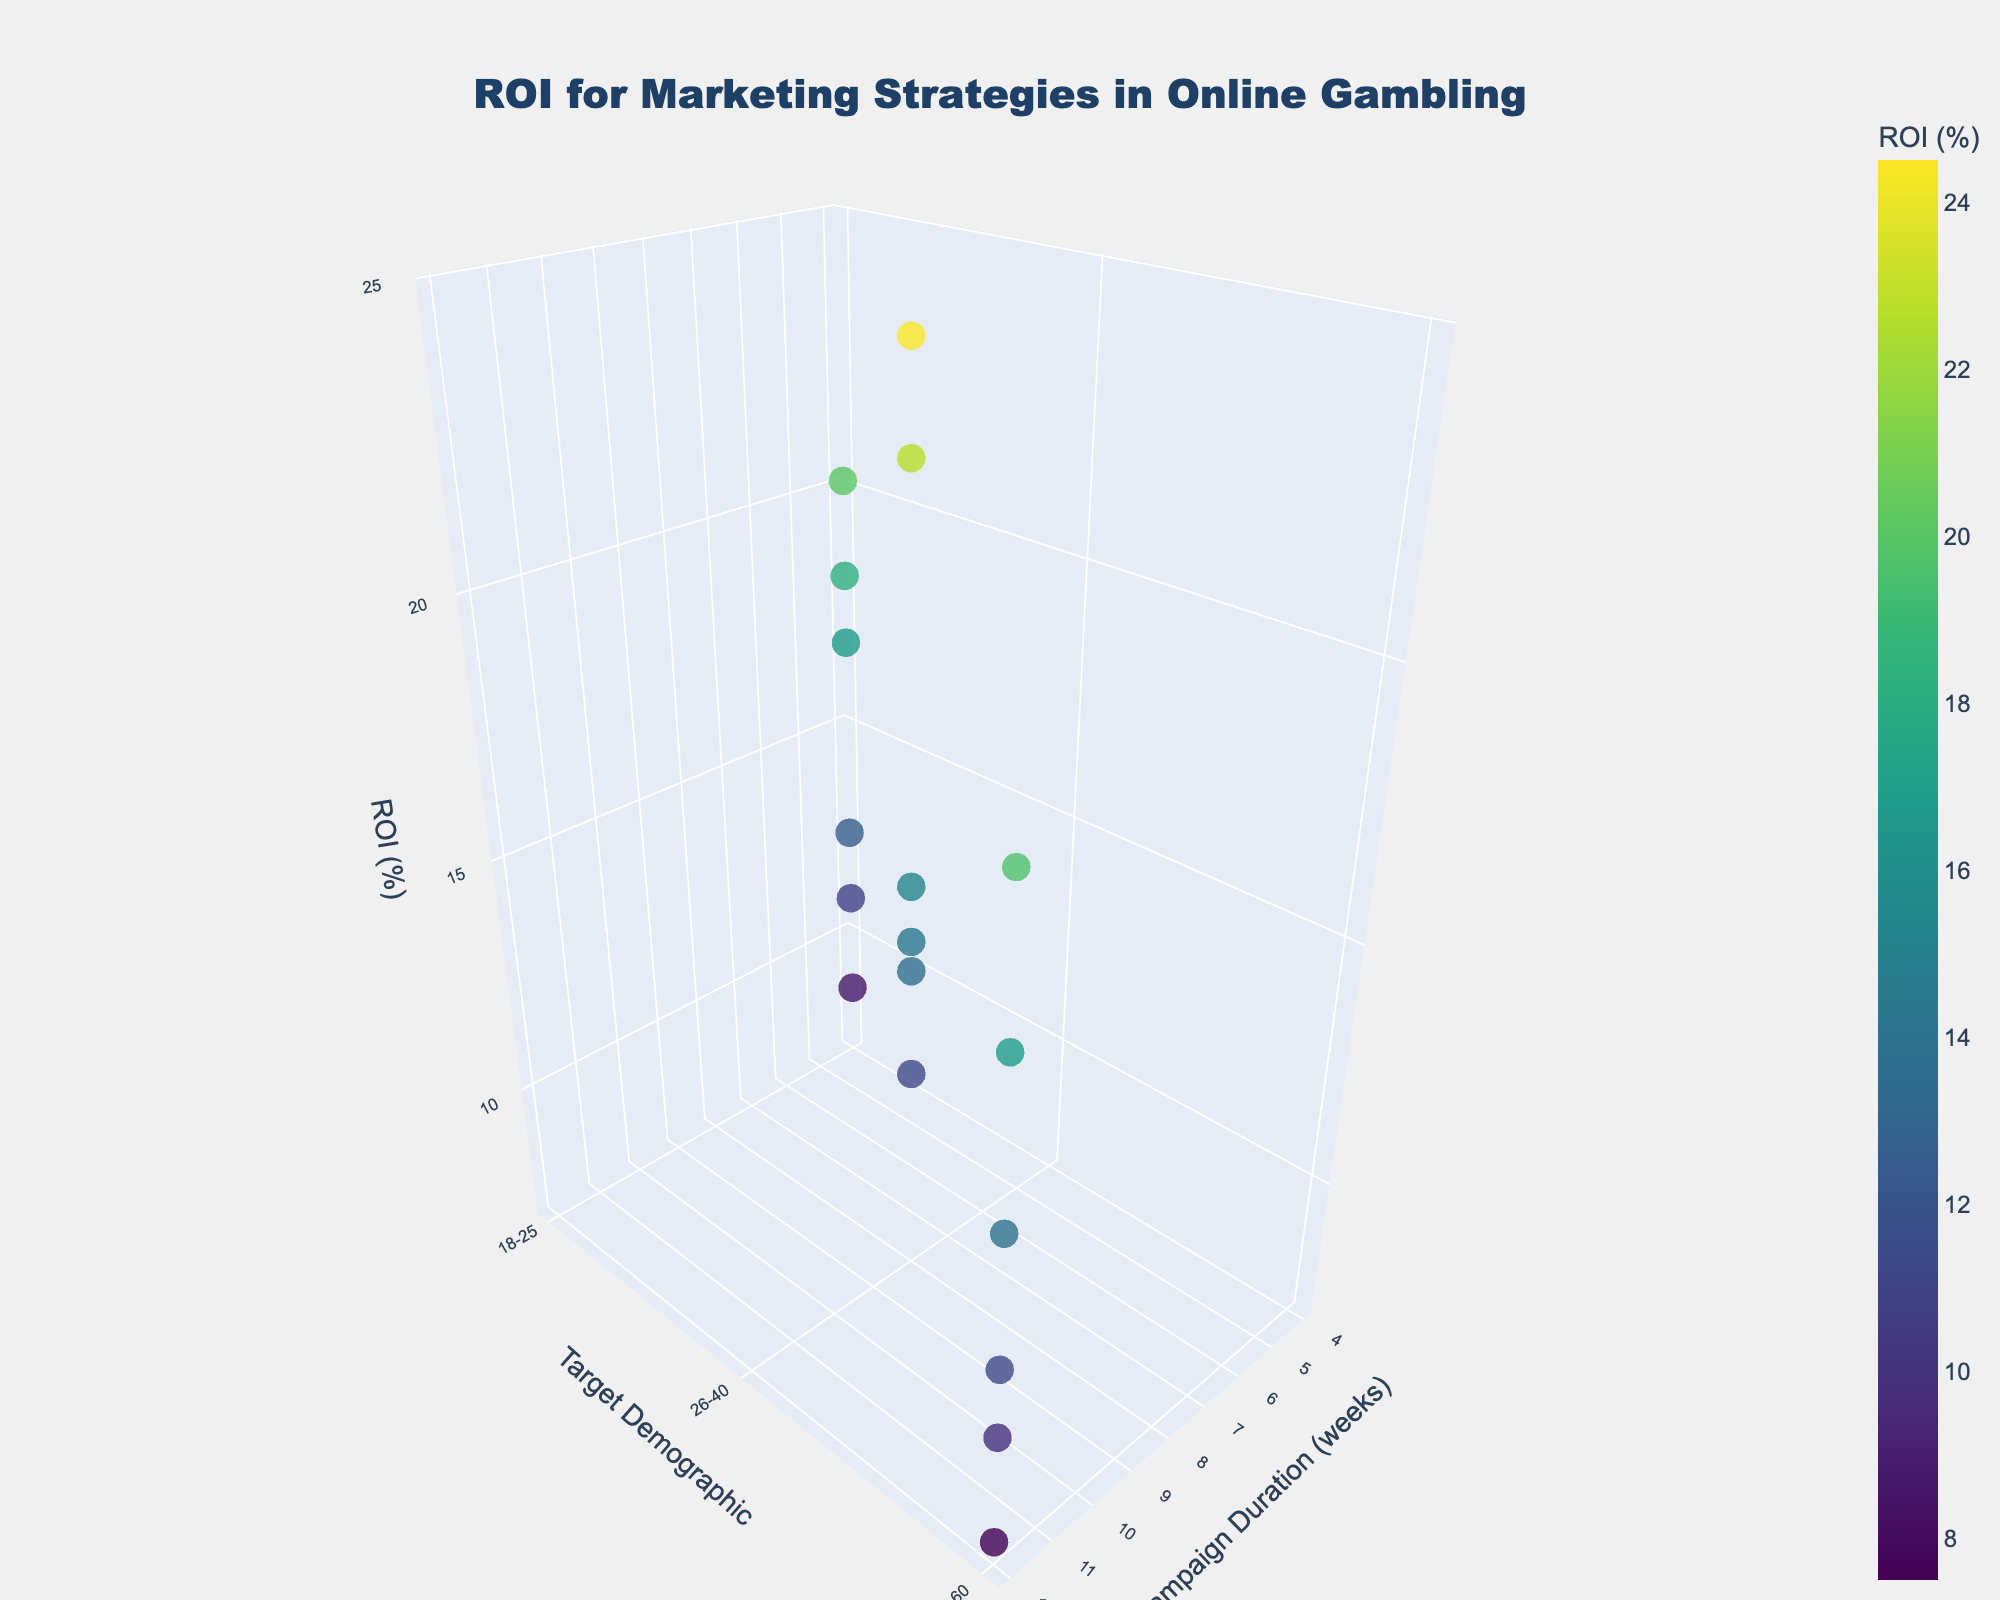What's the title of the figure? The title is displayed at the top center of the figure, in bold and larger font. It reads "ROI for Marketing Strategies in Online Gambling".
Answer: ROI for Marketing Strategies in Online Gambling What are the axes labels on the figure? The x, y, and z-axis labels are shown along each axis: "Campaign Duration (weeks)" for the x-axis, "Target Demographic" for the y-axis, and "ROI (%)" for the z-axis.
Answer: Campaign Duration (weeks), Target Demographic, ROI (%) How many target demographics are shown in the figure? By analyzing the y-axis, we see there are 3 distinct groups: 18-25, 26-40, and 41-60.
Answer: 3 Which marketing channel shows the highest ROI (%) for the 26-40 demographic? By examining the scatter points corresponding to the 26-40 demographic, we find that Affiliate Marketing has the highest ROI at 24.5%.
Answer: Affiliate Marketing For which marketing channel does the ROI (%) decrease as the campaign duration increases for the 41-60 demographic? Analyzing the scatter points for the 41-60 demographic across different campaign durations, we notice that for Influencer Partnerships, the ROI decreases as the campaign duration goes from 4 to 12 weeks (16.8% to 7.5%).
Answer: Influencer Partnerships What is the average ROI (%) for Email Marketing across all target demographics and campaign durations? Summing the ROI values for Email Marketing (8.6 + 11.4 + 13.8) and then dividing by 3 (the number of points) gives us (8.6 + 11.4 + 13.8) / 3 = 11.27%.
Answer: 11.27% Which marketing channel has the most consistently high ROI (%) across different campaign durations and demographics? By evaluating the scatter points’ color intensity and height across various demographics and durations, Affiliate Marketing shows consistently high ROI values, generally above 19%.
Answer: Affiliate Marketing For the 18-25 demographic, which campaign duration yields the lowest ROI (%)? Looking at the scatter points for the 18-25 demographic, we notice that Email Marketing at a 4-week duration yields the lowest ROI of 8.6%.
Answer: 4 weeks (Email Marketing) How does the ROI (%) for Search Engine Marketing change as campaign duration increases for the 26-40 demographic? Observing the scatter points for Search Engine Marketing in the 26-40 demographic, we see the ROI increases from 4 to 12 weeks (18.2% to 22.7%).
Answer: It increases Which target demographic shows the highest ROI (%) for Search Engine Marketing? By checking the highest ROI values for Search Engine Marketing across different demographics, we find that the 26-40 demographic has the highest ROI of 22.7%.
Answer: 26-40 